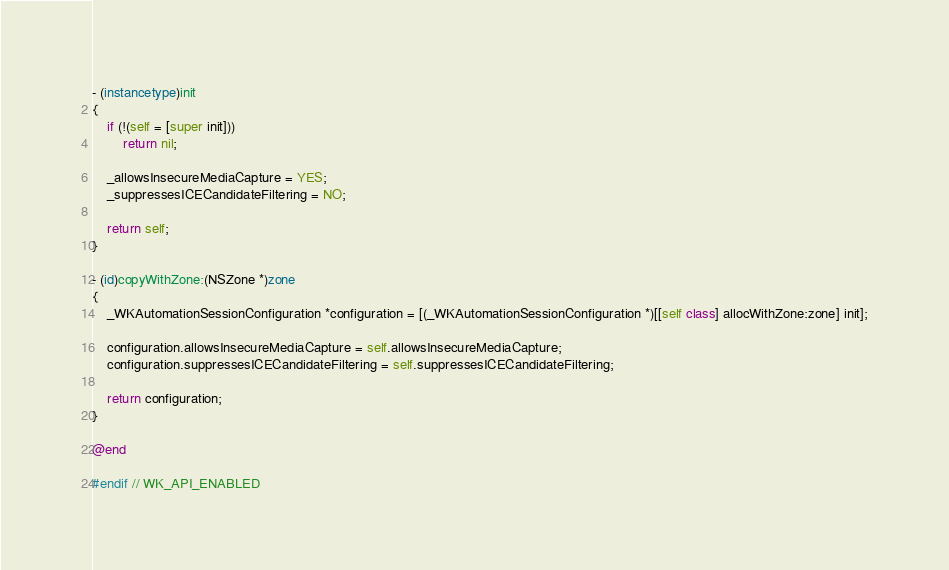Convert code to text. <code><loc_0><loc_0><loc_500><loc_500><_ObjectiveC_>- (instancetype)init
{
    if (!(self = [super init]))
        return nil;

    _allowsInsecureMediaCapture = YES;
    _suppressesICECandidateFiltering = NO;

    return self;
}

- (id)copyWithZone:(NSZone *)zone
{
    _WKAutomationSessionConfiguration *configuration = [(_WKAutomationSessionConfiguration *)[[self class] allocWithZone:zone] init];

    configuration.allowsInsecureMediaCapture = self.allowsInsecureMediaCapture;
    configuration.suppressesICECandidateFiltering = self.suppressesICECandidateFiltering;

    return configuration;
}

@end

#endif // WK_API_ENABLED
</code> 